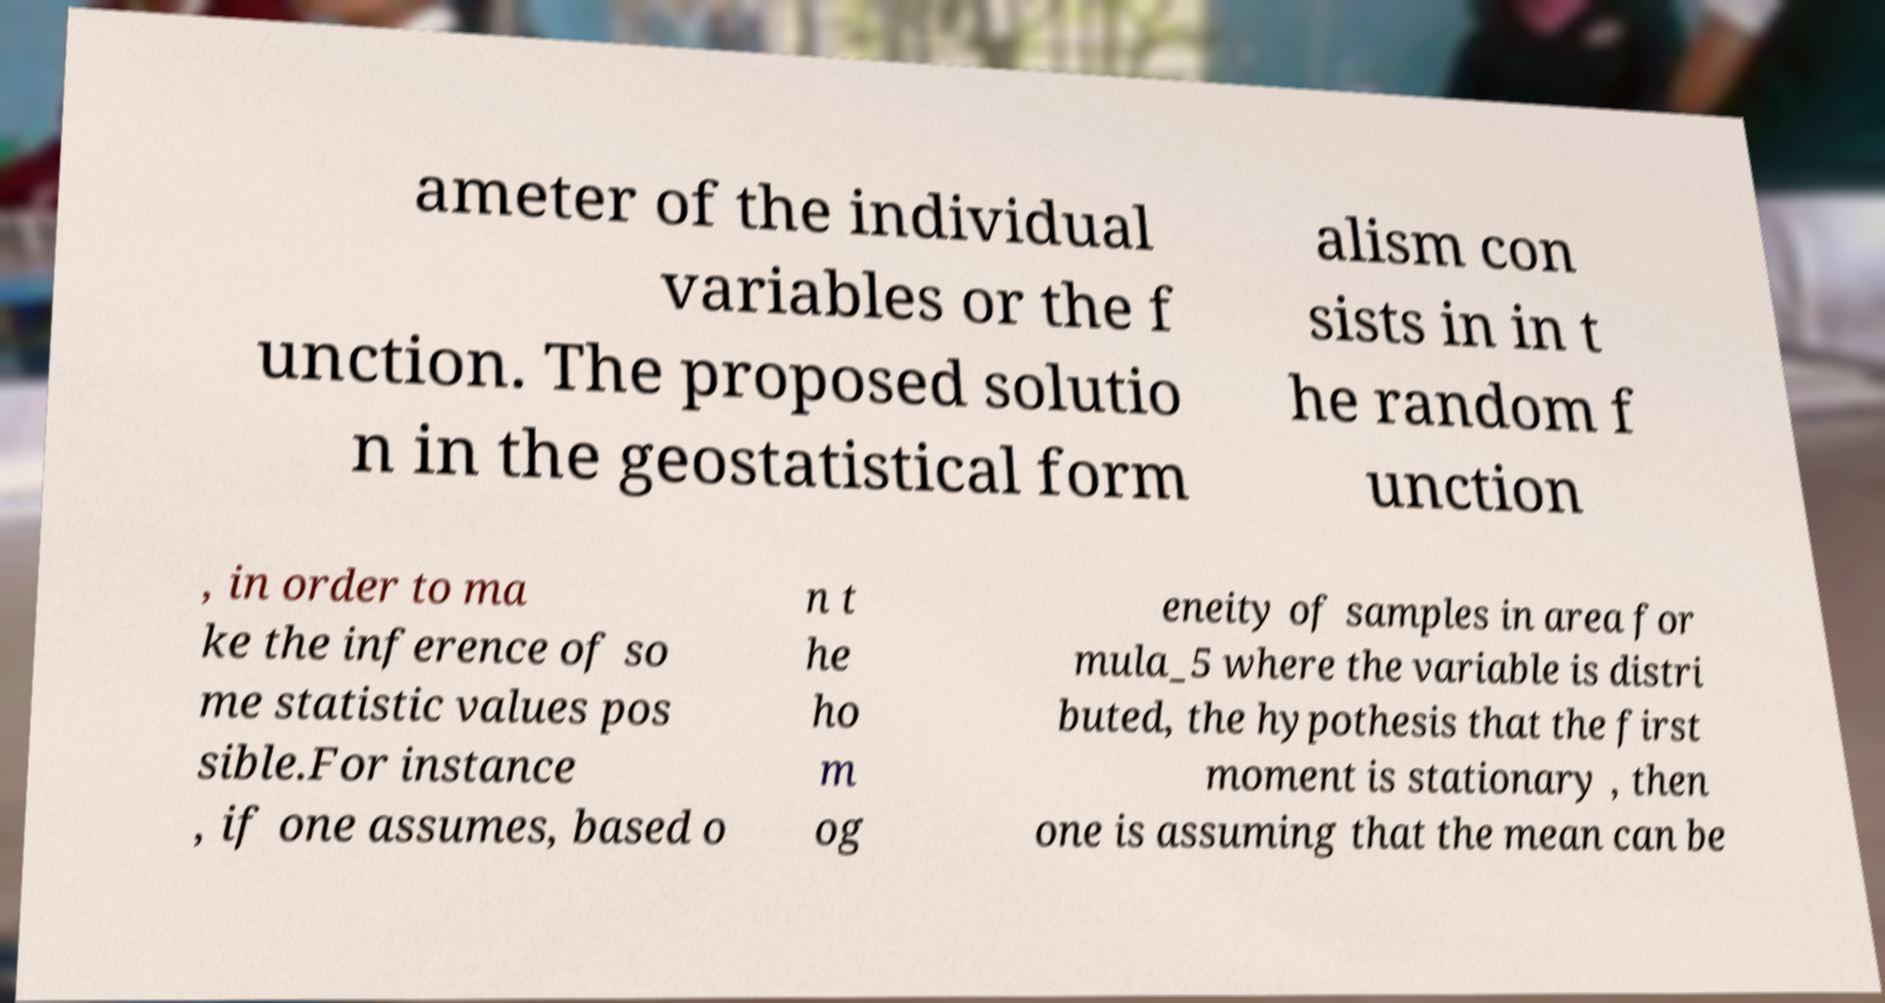Can you read and provide the text displayed in the image?This photo seems to have some interesting text. Can you extract and type it out for me? ameter of the individual variables or the f unction. The proposed solutio n in the geostatistical form alism con sists in in t he random f unction , in order to ma ke the inference of so me statistic values pos sible.For instance , if one assumes, based o n t he ho m og eneity of samples in area for mula_5 where the variable is distri buted, the hypothesis that the first moment is stationary , then one is assuming that the mean can be 